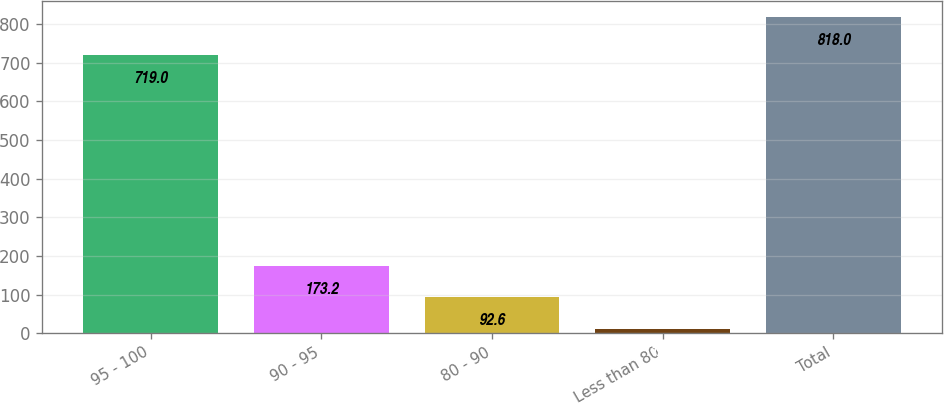<chart> <loc_0><loc_0><loc_500><loc_500><bar_chart><fcel>95 - 100<fcel>90 - 95<fcel>80 - 90<fcel>Less than 80<fcel>Total<nl><fcel>719<fcel>173.2<fcel>92.6<fcel>12<fcel>818<nl></chart> 